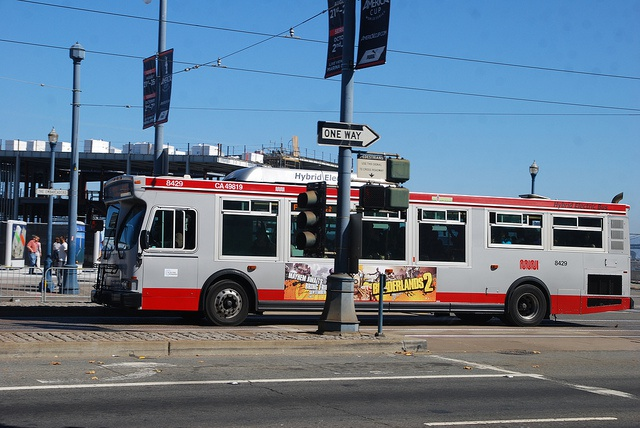Describe the objects in this image and their specific colors. I can see bus in gray, black, darkgray, lightgray, and brown tones, traffic light in gray and black tones, traffic light in gray, black, and darkgray tones, people in gray, black, lightgray, and darkgray tones, and people in gray, black, brown, navy, and salmon tones in this image. 